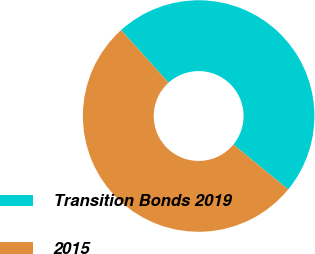Convert chart. <chart><loc_0><loc_0><loc_500><loc_500><pie_chart><fcel>Transition Bonds 2019<fcel>2015<nl><fcel>47.62%<fcel>52.38%<nl></chart> 